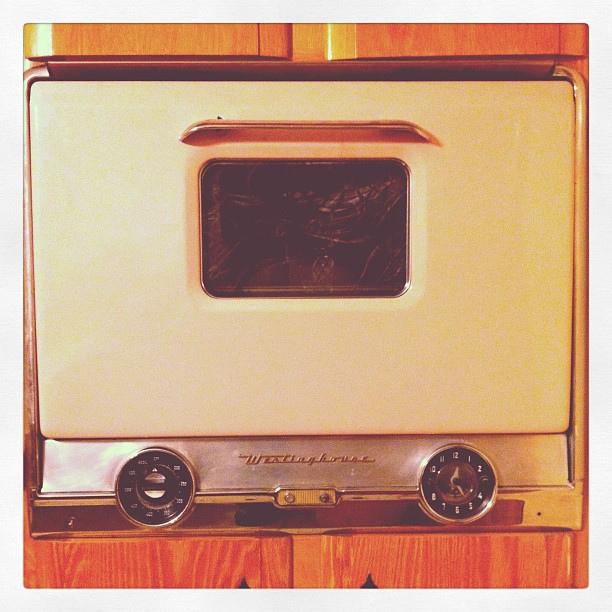Does this item have a clock on it?
Keep it brief. Yes. What is the cabinet made out of?
Quick response, please. Wood. Is this a modern appliance?
Give a very brief answer. No. 